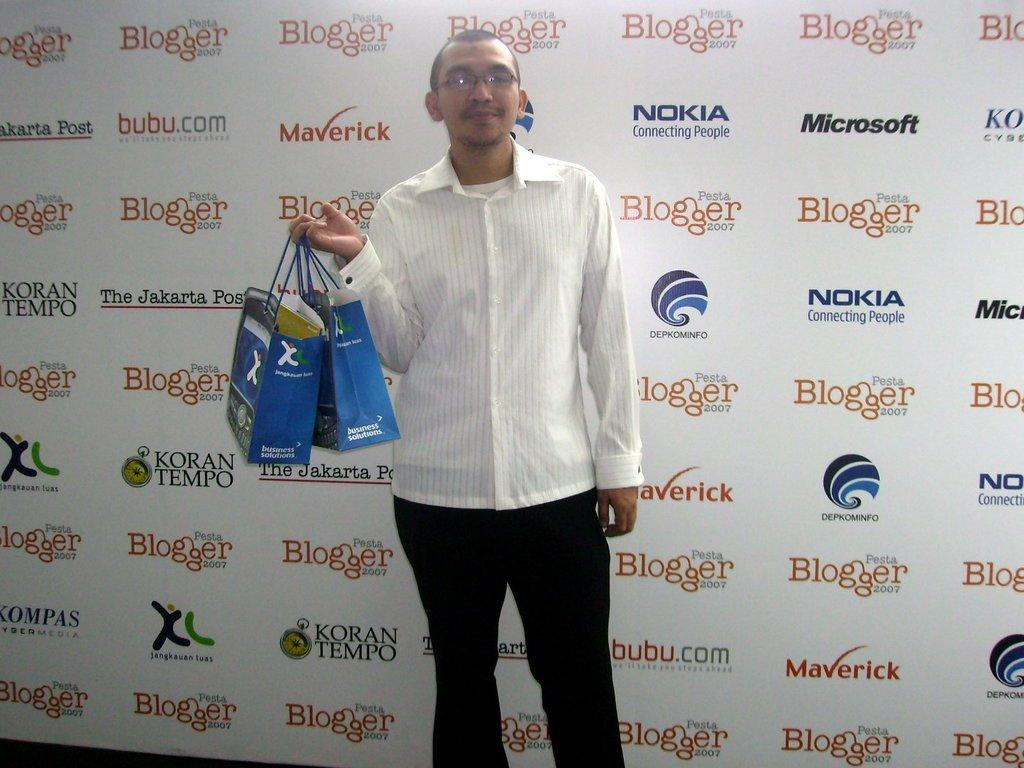What is the main subject of the image? There is a person standing in the center of the image. What is the person holding in the image? The person is holding some bags. What can be seen in the background of the image? There is a board in the background of the image. What is written on the board? There is text on the board. What type of hydrant is present in the image? There is no hydrant present in the image. How does the committee interact with the person in the image? There is no committee present in the image, so it is not possible to determine how they might interact with the person. 